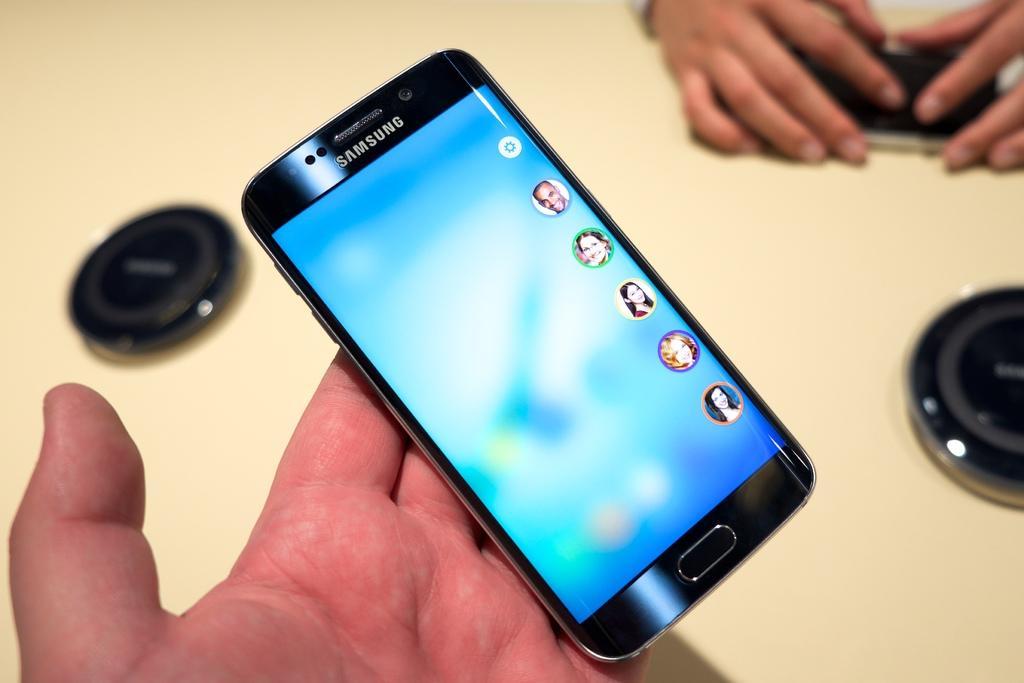Can you describe this image briefly? In this image, we can see a few person's hands. Among them, we can see a person's hand holding a mobile phone and another person's hands holding an object. We can see some black colored objects on the surface. 